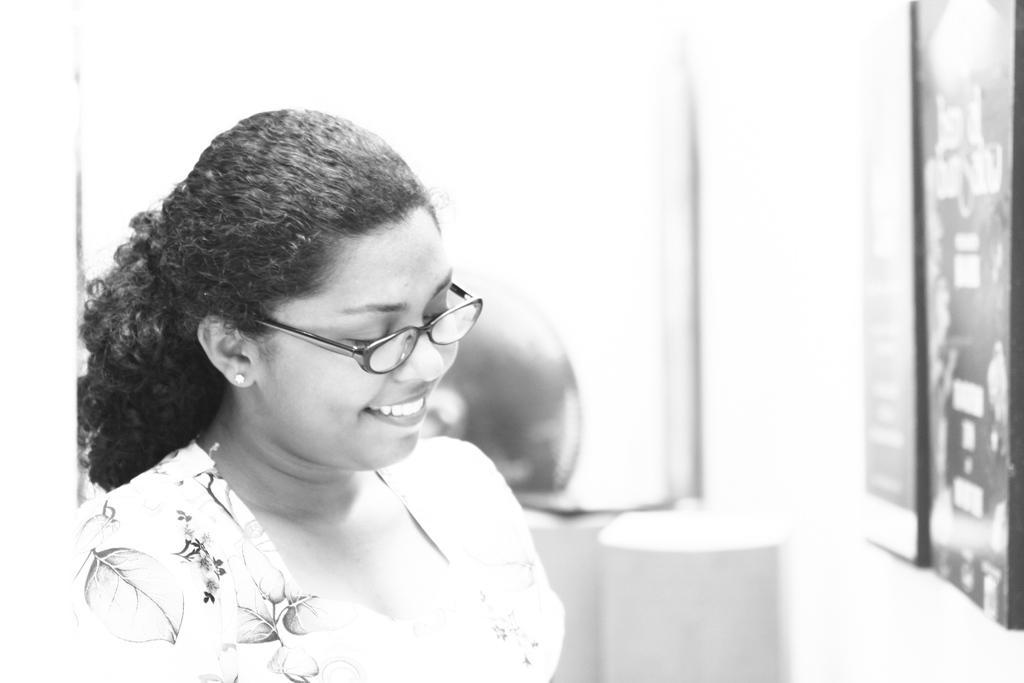Describe this image in one or two sentences. This is a black and white image. In the center of the image we can see women. On the right side of the image we can see photo frames to the wall. 